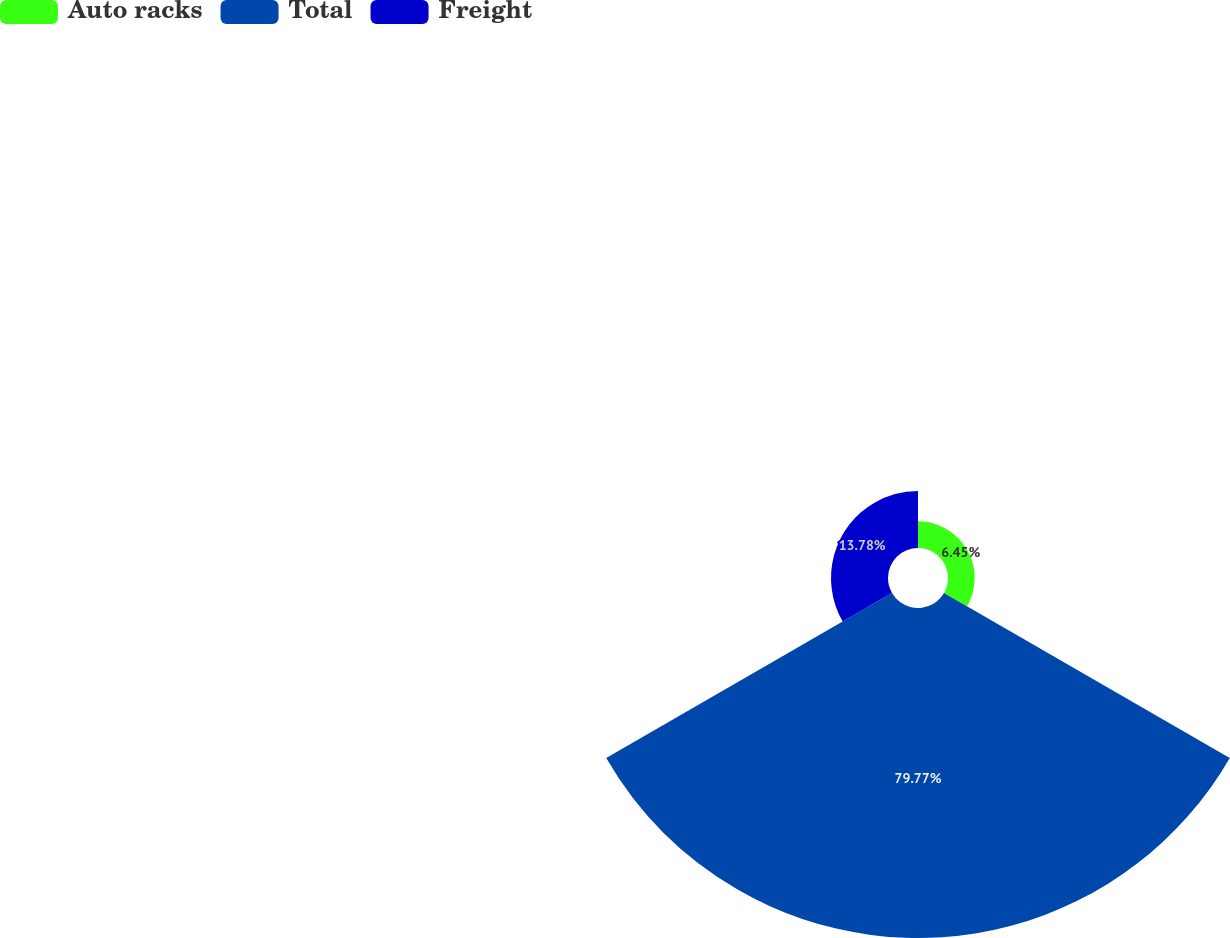<chart> <loc_0><loc_0><loc_500><loc_500><pie_chart><fcel>Auto racks<fcel>Total<fcel>Freight<nl><fcel>6.45%<fcel>79.78%<fcel>13.78%<nl></chart> 